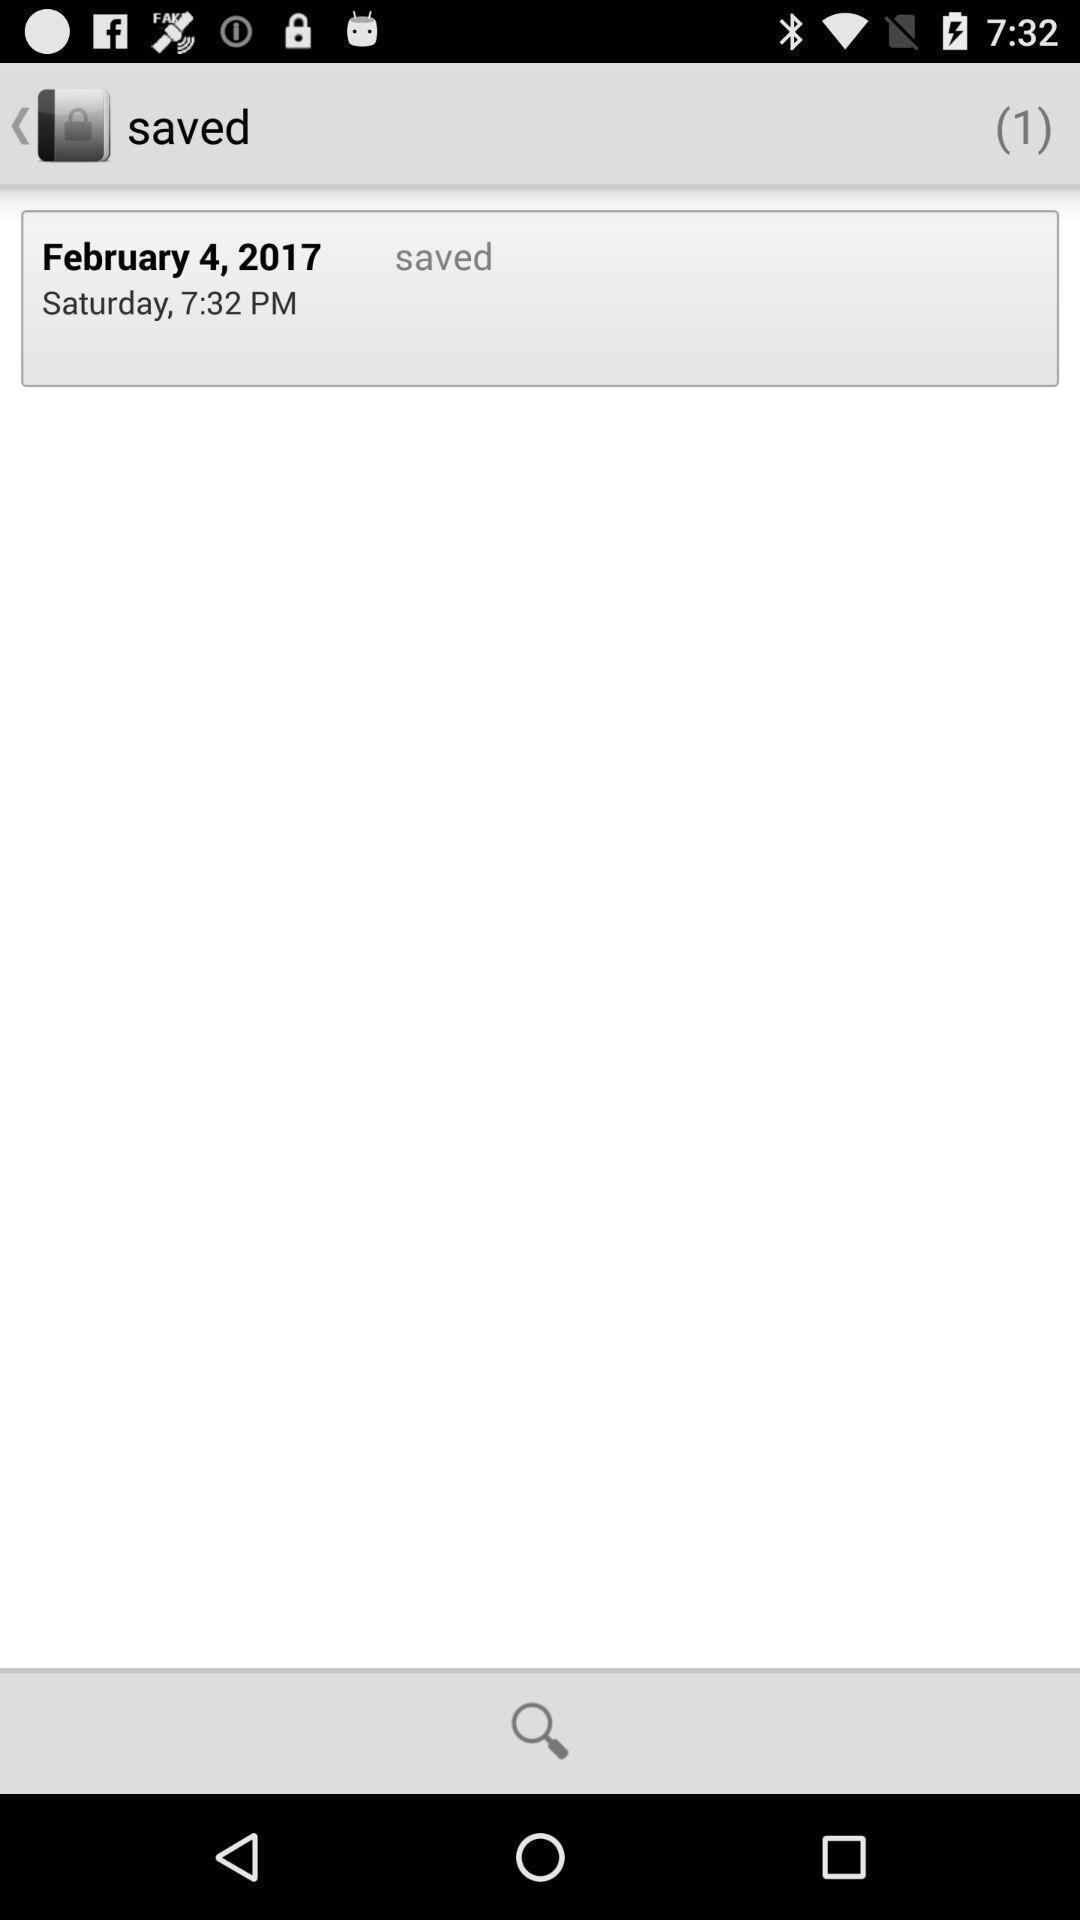Describe the content in this image. Screen showing date and year in saved. 